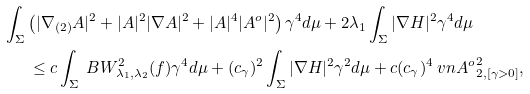Convert formula to latex. <formula><loc_0><loc_0><loc_500><loc_500>\int _ { \Sigma } & \left ( | \nabla _ { ( 2 ) } A | ^ { 2 } + | A | ^ { 2 } | \nabla A | ^ { 2 } + | A | ^ { 4 } | A ^ { o } | ^ { 2 } \right ) \gamma ^ { 4 } d \mu + 2 \lambda _ { 1 } \int _ { \Sigma } | \nabla H | ^ { 2 } \gamma ^ { 4 } d \mu \\ & \, \leq c \int _ { \Sigma } \ B W ^ { 2 } _ { \lambda _ { 1 } , \lambda _ { 2 } } ( f ) \gamma ^ { 4 } d \mu + ( c _ { \gamma } ) ^ { 2 } \int _ { \Sigma } | \nabla H | ^ { 2 } \gamma ^ { 2 } d \mu + c ( c _ { \gamma } ) ^ { 4 } \ v n { A ^ { o } } ^ { 2 } _ { 2 , [ \gamma > 0 ] } ,</formula> 